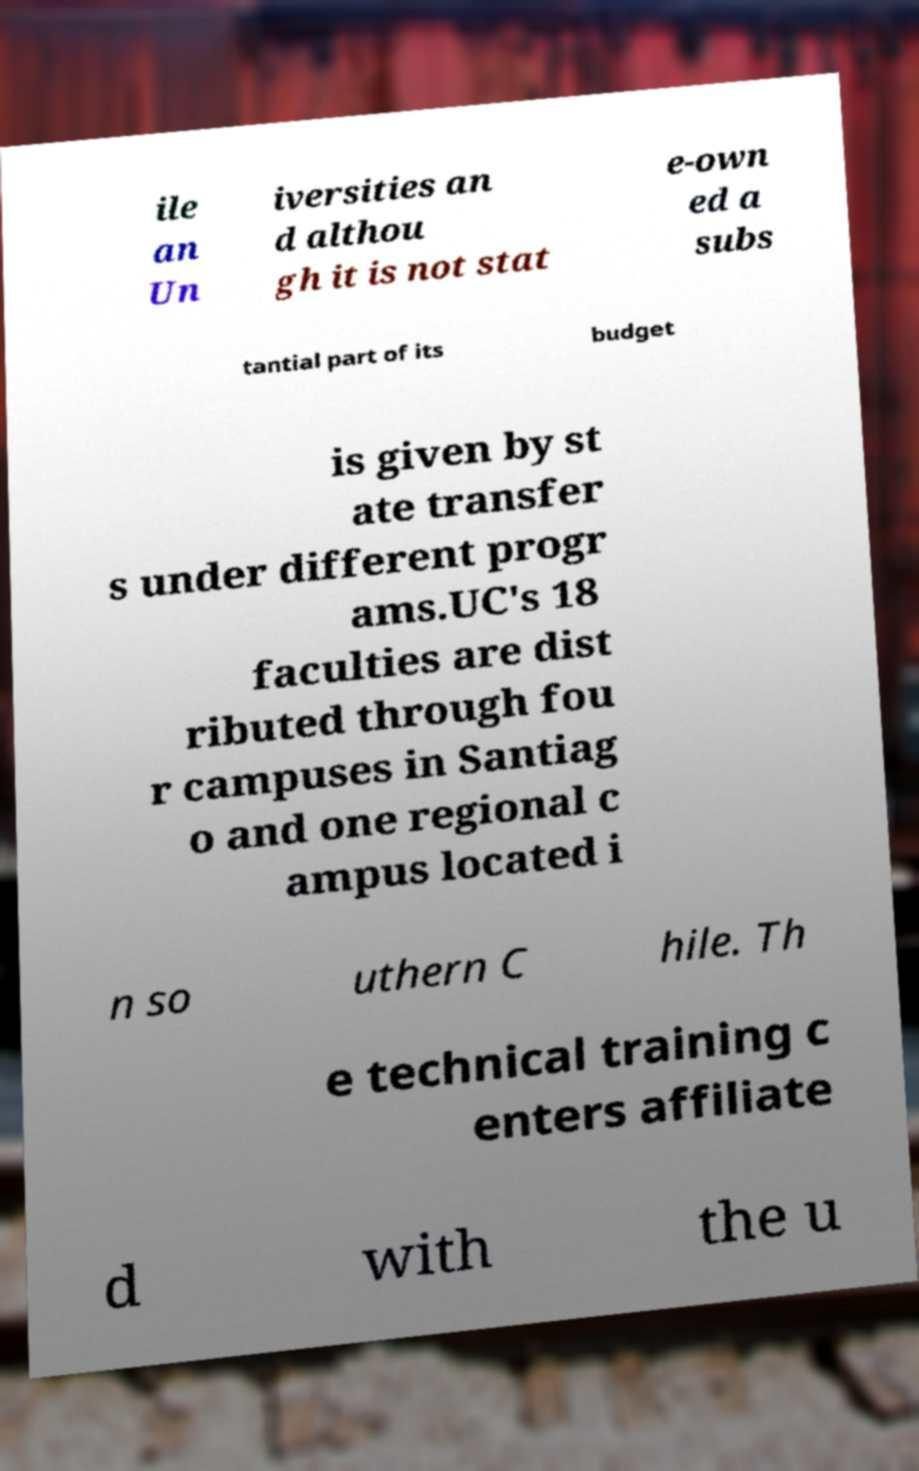What messages or text are displayed in this image? I need them in a readable, typed format. ile an Un iversities an d althou gh it is not stat e-own ed a subs tantial part of its budget is given by st ate transfer s under different progr ams.UC's 18 faculties are dist ributed through fou r campuses in Santiag o and one regional c ampus located i n so uthern C hile. Th e technical training c enters affiliate d with the u 